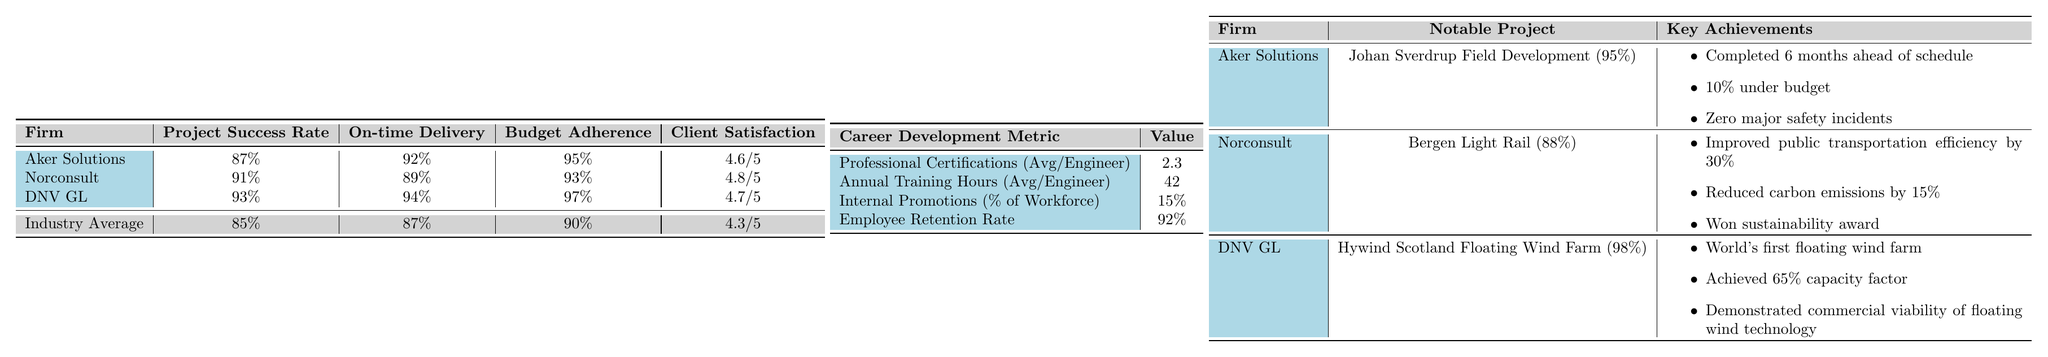What is the Project Success Rate of Aker Solutions? The table shows the Project Success Rate for Aker Solutions as 87%.
Answer: 87% Which firm has the highest Client Satisfaction rating? According to the table, Norconsult has the highest Client Satisfaction rating at 4.8 out of 5.
Answer: Norconsult What percentage of the workforce in Norwegian engineering firms is promoted internally? The table indicates that 15% of the workforce has Internal Promotions.
Answer: 15% How does DNV GL's Budget Adherence compare to the industry average? DNV GL has a Budget Adherence of 97%, which is higher than the industry average of 90%.
Answer: It is higher What is the difference in On-time Delivery between Aker Solutions and Norconsult? Aker Solutions has an On-time Delivery of 92% while Norconsult has 89%. The difference is 92% - 89% = 3%.
Answer: 3% What is the average Client Satisfaction across the three firms? The Client Satisfaction values are 4.6, 4.8, and 4.7. The average is (4.6 + 4.8 + 4.7) / 3 = 4.7.
Answer: 4.7 Are all firms above the industry average for Project Success Rate? Aker Solutions (87%), Norconsult (91%), and DNV GL (93%) all exceed the industry average of 85%.
Answer: Yes What was the success rate of the notable project for Norconsult? The table shows that the success rate for the Bergen Light Rail project by Norconsult is 88%.
Answer: 88% If we were to compare the average On-time Delivery rates of the three firms, which one exceeds the industry average? Aker Solutions (92%), Norconsult (89%), and DNV GL (94%) have On-time Delivery rates above the industry average of 87%.
Answer: All three firms exceed it What notable achievement did DNV GL accomplish with the Hywind Scotland Floating Wind Farm? The notable achievement highlighted is that it was the world's first floating wind farm.
Answer: World's first floating wind farm 